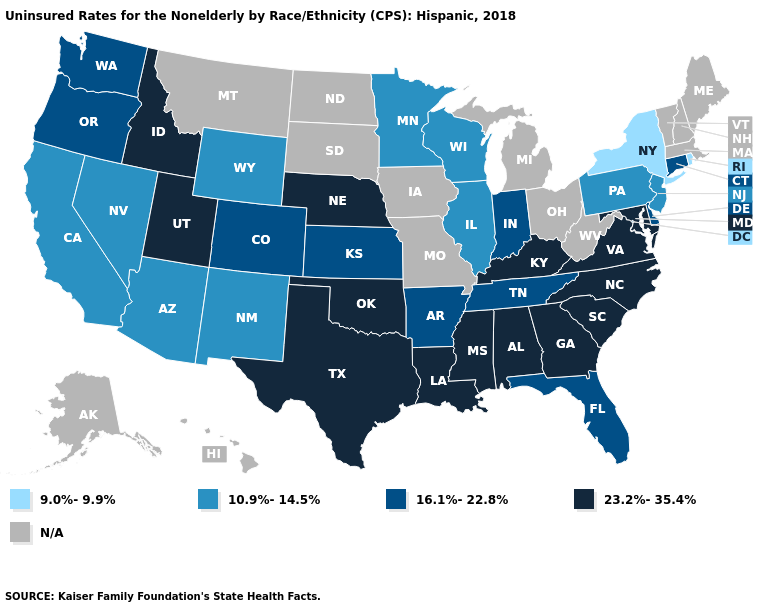Name the states that have a value in the range N/A?
Give a very brief answer. Alaska, Hawaii, Iowa, Maine, Massachusetts, Michigan, Missouri, Montana, New Hampshire, North Dakota, Ohio, South Dakota, Vermont, West Virginia. Does Nevada have the lowest value in the West?
Write a very short answer. Yes. Name the states that have a value in the range 9.0%-9.9%?
Write a very short answer. New York, Rhode Island. Does Nebraska have the highest value in the MidWest?
Short answer required. Yes. Which states have the highest value in the USA?
Quick response, please. Alabama, Georgia, Idaho, Kentucky, Louisiana, Maryland, Mississippi, Nebraska, North Carolina, Oklahoma, South Carolina, Texas, Utah, Virginia. Among the states that border Louisiana , does Arkansas have the highest value?
Write a very short answer. No. What is the lowest value in the Northeast?
Keep it brief. 9.0%-9.9%. What is the highest value in the USA?
Concise answer only. 23.2%-35.4%. How many symbols are there in the legend?
Short answer required. 5. What is the highest value in states that border West Virginia?
Quick response, please. 23.2%-35.4%. Does Delaware have the lowest value in the South?
Be succinct. Yes. What is the value of Illinois?
Be succinct. 10.9%-14.5%. Name the states that have a value in the range N/A?
Give a very brief answer. Alaska, Hawaii, Iowa, Maine, Massachusetts, Michigan, Missouri, Montana, New Hampshire, North Dakota, Ohio, South Dakota, Vermont, West Virginia. What is the value of Massachusetts?
Keep it brief. N/A. 